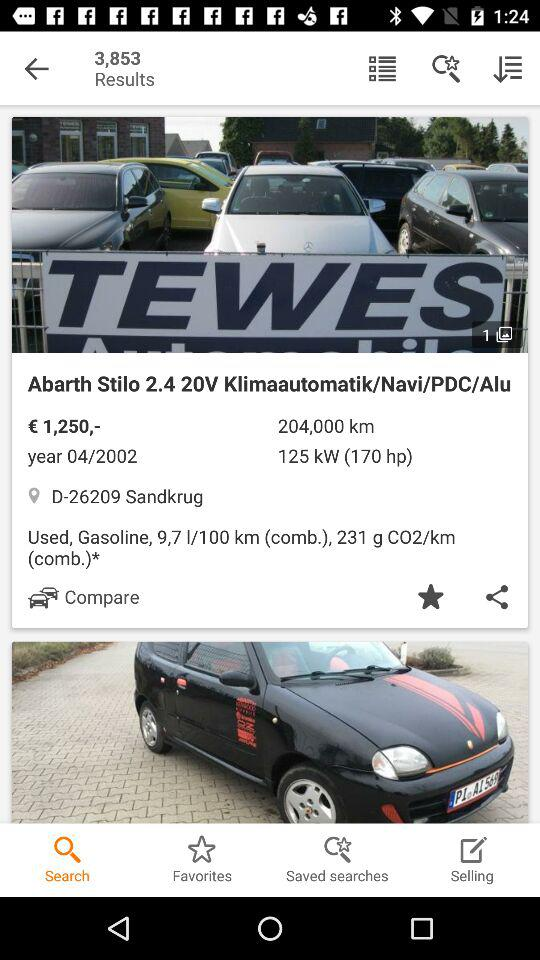What is the range?
When the provided information is insufficient, respond with <no answer>. <no answer> 